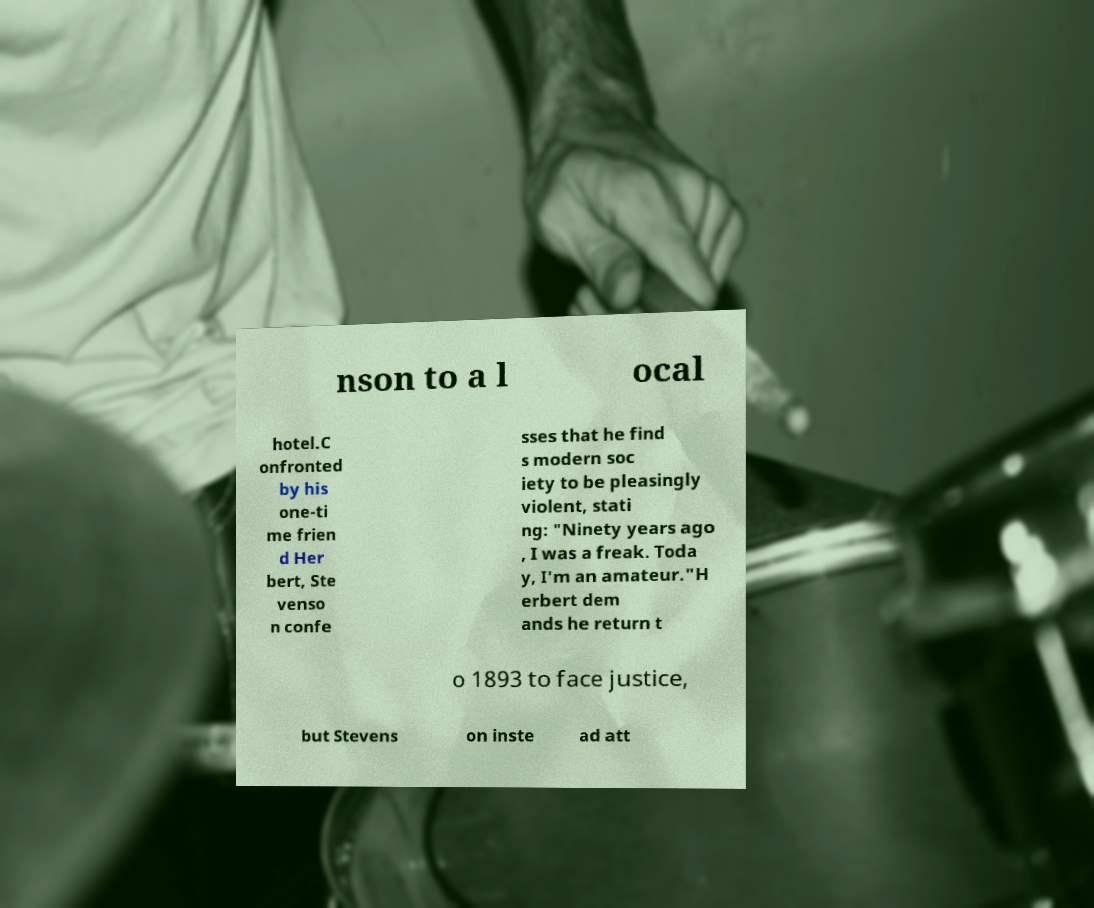Can you read and provide the text displayed in the image?This photo seems to have some interesting text. Can you extract and type it out for me? nson to a l ocal hotel.C onfronted by his one-ti me frien d Her bert, Ste venso n confe sses that he find s modern soc iety to be pleasingly violent, stati ng: "Ninety years ago , I was a freak. Toda y, I'm an amateur."H erbert dem ands he return t o 1893 to face justice, but Stevens on inste ad att 